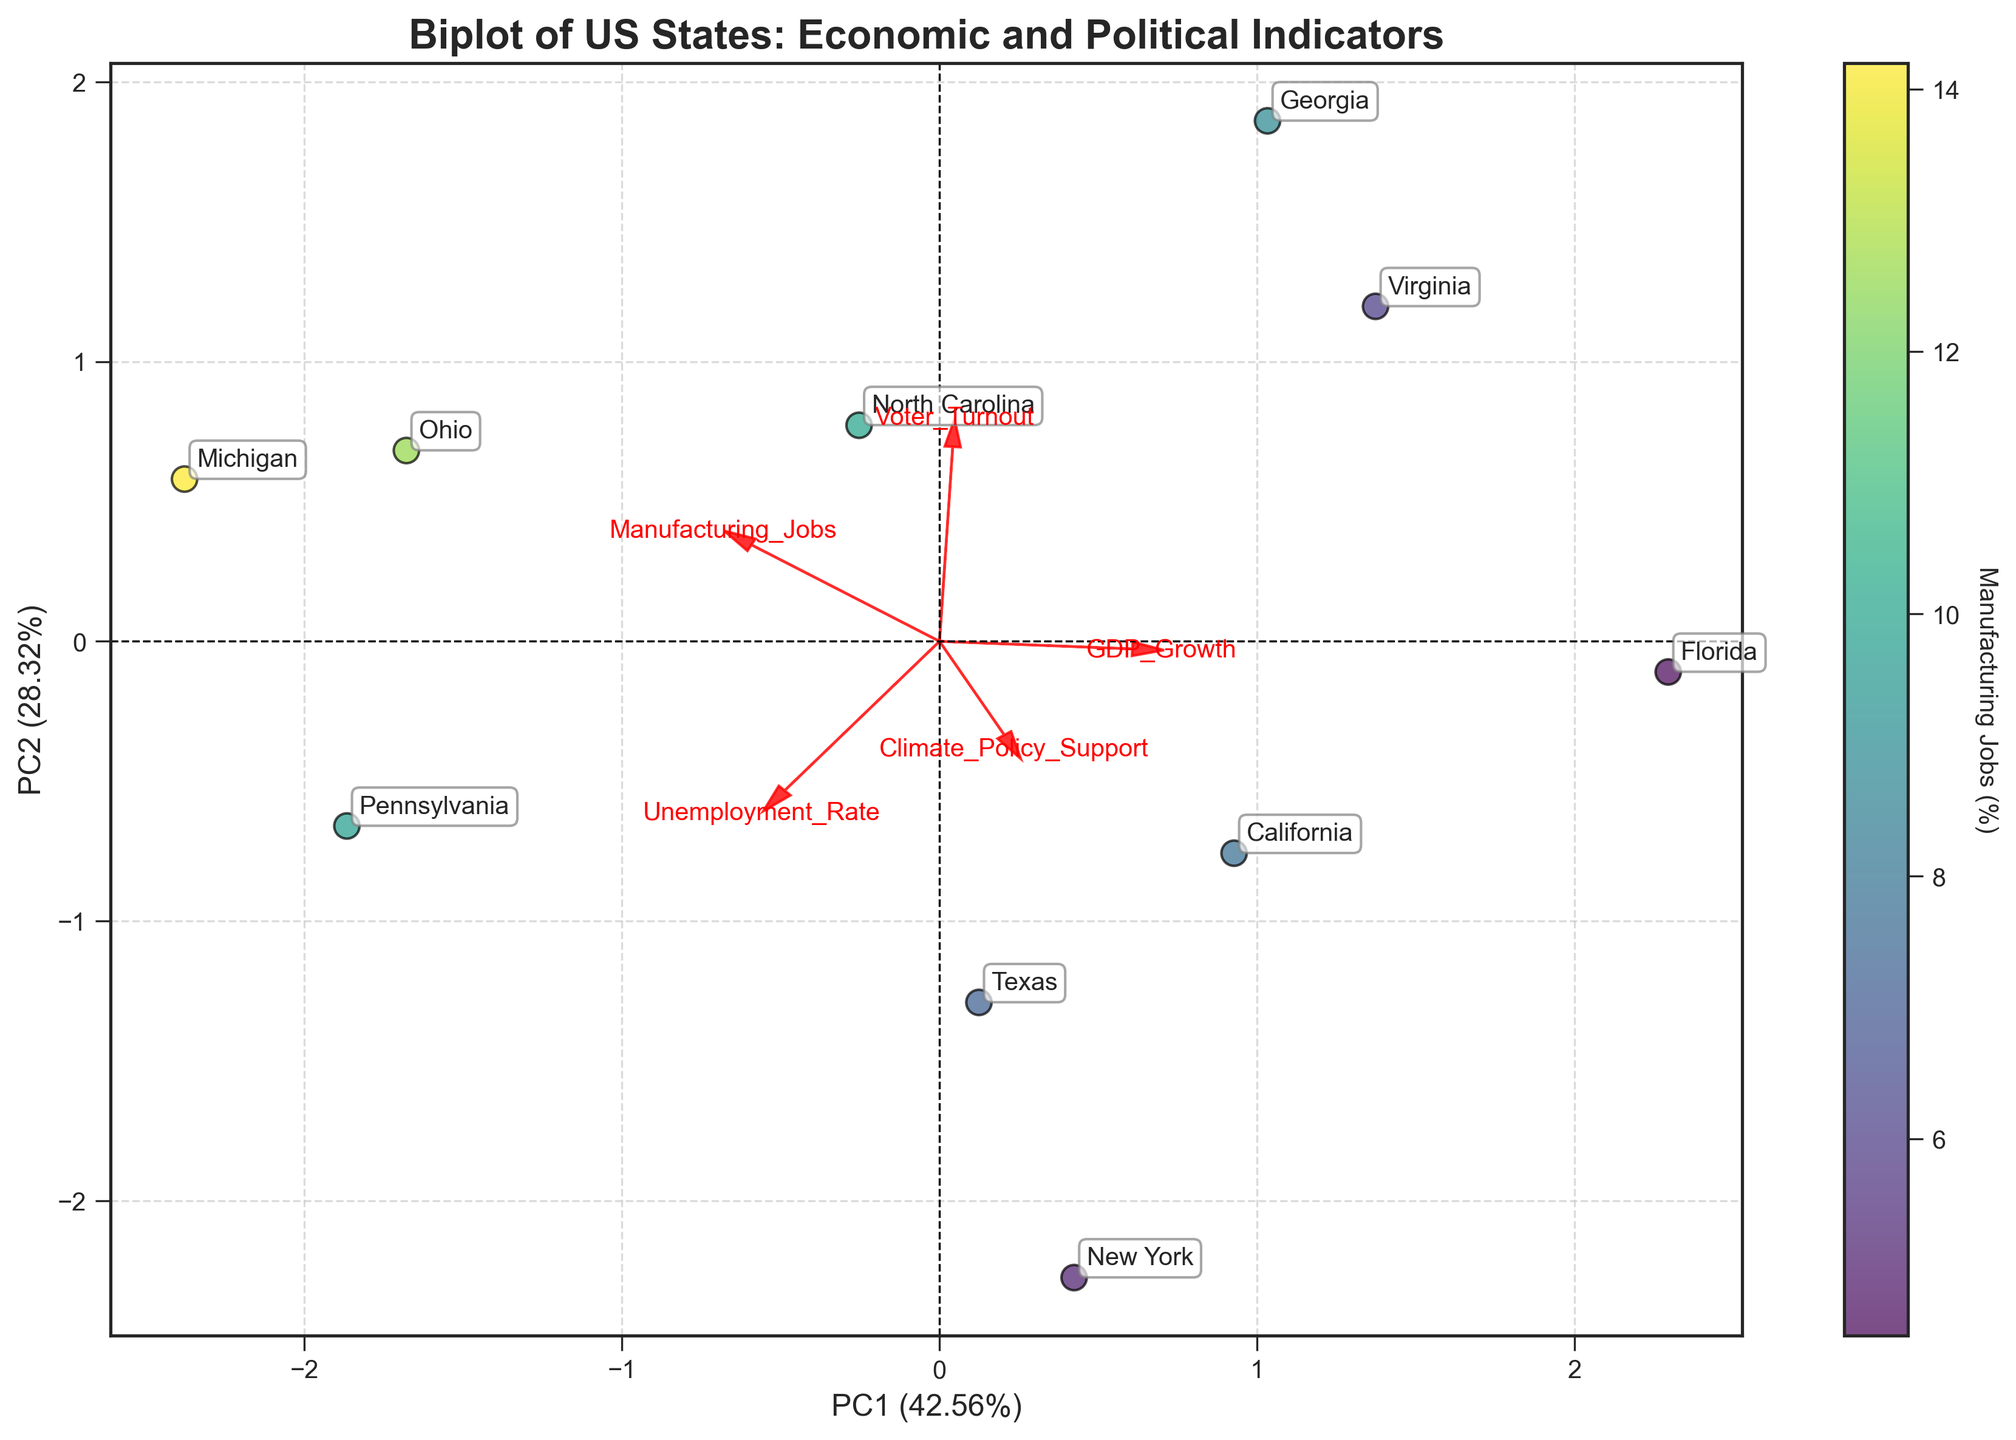What's the title of the biplot? The title of the biplot is located at the top of the figure, making it easy to identify.
Answer: Biplot of US States: Economic and Political Indicators How many states are represented in the biplot? Each state is plotted as an individual data point on the biplot, with state labels. Counting these labels gives the number of states.
Answer: 10 Which state has the highest representation of manufacturing jobs based on the color scale? The color scale (viridis) indicates the percentage of manufacturing jobs, so the state represented by the darkest or most prominent color corresponds to the highest percentage of manufacturing jobs.
Answer: Michigan Do any states with high climate policy support also have high voter turnout? By locating the data points with high Climate_Policy_Support values and checking their corresponding Voter_Turnout values, we can determine if there's a correlation between the two.
Answer: Yes (California and New York) Which principal component (PC) explains the most variance? The explained variance of each principal component is labeled on the respective axis. The PC with the higher percentage indicates which one explains more variance.
Answer: PC1 Is there a state that has both low unemployment and high GDP growth? By checking the states positioned favorably along the axes corresponding to Unemployment_Rate and GDP_Growth vectors, we can identify any state that meets this criterion.
Answer: Georgia Do states with higher manufacturing jobs tend to support climate policies more? By observing the coloring of states and their projected position relative to the Climate_Policy_Support vector, we can infer any existing trends.
Answer: No clear trend Which feature vector points most closely in the same direction as the voter turnout vector? By visually comparing the directions of the arrows (feature vectors), the feature vector that aligns most closely with the Voter_Turnout vector can be identified.
Answer: GDP_Growth Which state appears to be an outlier in terms of climate policy support and why? By examining the biplot, we can look for states that are significantly distant from others in terms of Climate_Policy_Support.
Answer: California (high Climate_Policy_Support) How is the color scale used to represent a specific economic indicator? The color scale represents the percentage of manufacturing jobs in each state, with different shades indicating different percentage ranges.
Answer: Manufacturing Jobs (%) 